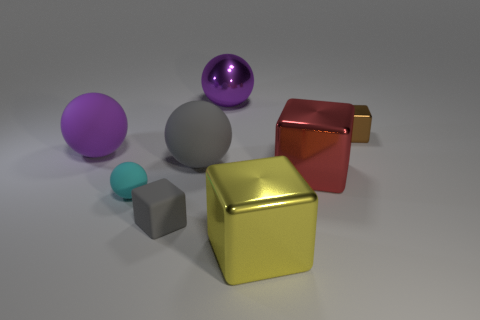Imagining these objects are part of a collection, what might the theme of the collection be? If these objects were part of a collection, the theme might be 'Geometric Shapes and Textures'. Each object represents a fundamental geometric shape, and the collection showcases different surface finishes such as metallic, matte, and glossy. This assortment could be used to explore the interplay of light, color, and texture on various geometric forms. 